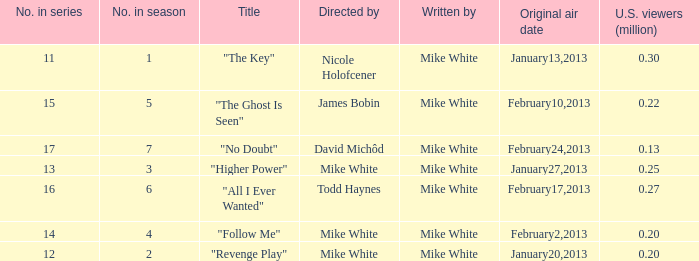Who directed the episode that have 0.25 million u.s viewers Mike White. 